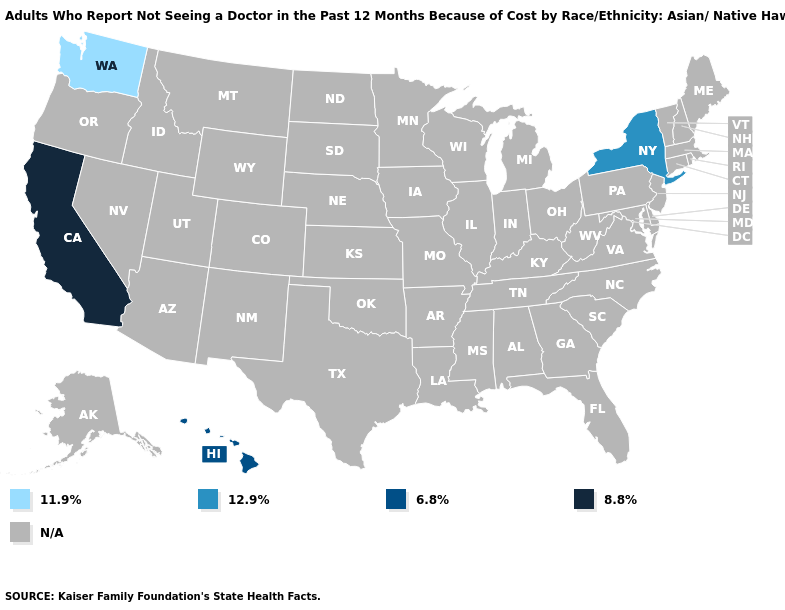What is the value of Kentucky?
Write a very short answer. N/A. Which states have the highest value in the USA?
Write a very short answer. California. What is the value of Alabama?
Concise answer only. N/A. Name the states that have a value in the range 6.8%?
Be succinct. Hawaii. What is the value of Iowa?
Answer briefly. N/A. Among the states that border Massachusetts , which have the lowest value?
Quick response, please. New York. What is the highest value in the USA?
Answer briefly. 8.8%. What is the highest value in the USA?
Short answer required. 8.8%. What is the value of Minnesota?
Short answer required. N/A. What is the value of West Virginia?
Be succinct. N/A. Name the states that have a value in the range 6.8%?
Concise answer only. Hawaii. Name the states that have a value in the range 12.9%?
Be succinct. New York. Name the states that have a value in the range N/A?
Concise answer only. Alabama, Alaska, Arizona, Arkansas, Colorado, Connecticut, Delaware, Florida, Georgia, Idaho, Illinois, Indiana, Iowa, Kansas, Kentucky, Louisiana, Maine, Maryland, Massachusetts, Michigan, Minnesota, Mississippi, Missouri, Montana, Nebraska, Nevada, New Hampshire, New Jersey, New Mexico, North Carolina, North Dakota, Ohio, Oklahoma, Oregon, Pennsylvania, Rhode Island, South Carolina, South Dakota, Tennessee, Texas, Utah, Vermont, Virginia, West Virginia, Wisconsin, Wyoming. 